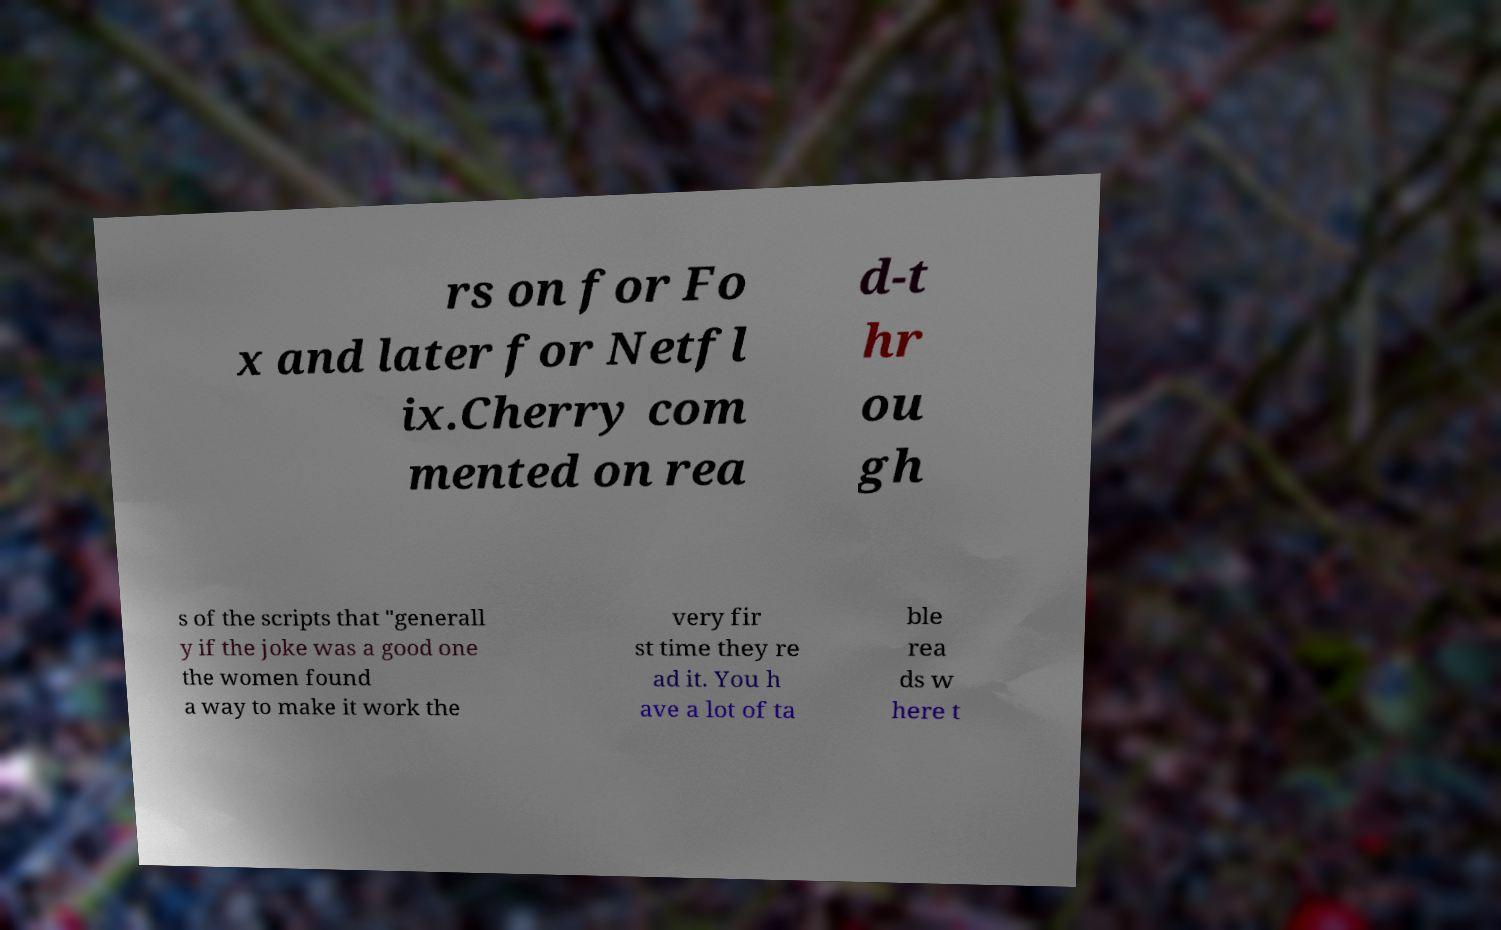I need the written content from this picture converted into text. Can you do that? rs on for Fo x and later for Netfl ix.Cherry com mented on rea d-t hr ou gh s of the scripts that "generall y if the joke was a good one the women found a way to make it work the very fir st time they re ad it. You h ave a lot of ta ble rea ds w here t 